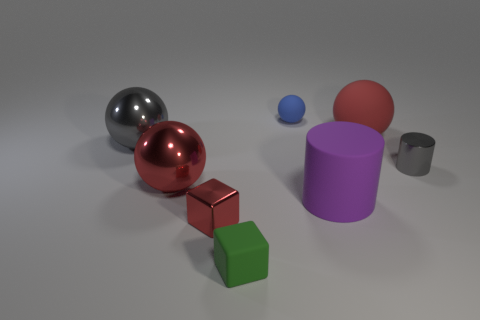Do the rubber sphere in front of the small matte sphere and the small metallic block have the same color?
Keep it short and to the point. Yes. How many other objects are the same size as the green thing?
Provide a short and direct response. 3. The metallic ball that is the same color as the small cylinder is what size?
Your response must be concise. Large. Are there any shiny cubes behind the matte cylinder?
Your answer should be very brief. No. Are there more gray shiny balls to the right of the purple rubber object than brown shiny things?
Provide a succinct answer. No. Is there a large rubber cylinder that has the same color as the tiny matte cube?
Your answer should be very brief. No. What color is the matte sphere that is the same size as the gray metal sphere?
Offer a very short reply. Red. Are there any big red spheres in front of the red ball left of the purple matte object?
Provide a short and direct response. No. There is a big red object behind the shiny cylinder; what is its material?
Make the answer very short. Rubber. Are the gray thing that is on the left side of the green matte thing and the big red thing right of the tiny red shiny cube made of the same material?
Offer a very short reply. No. 